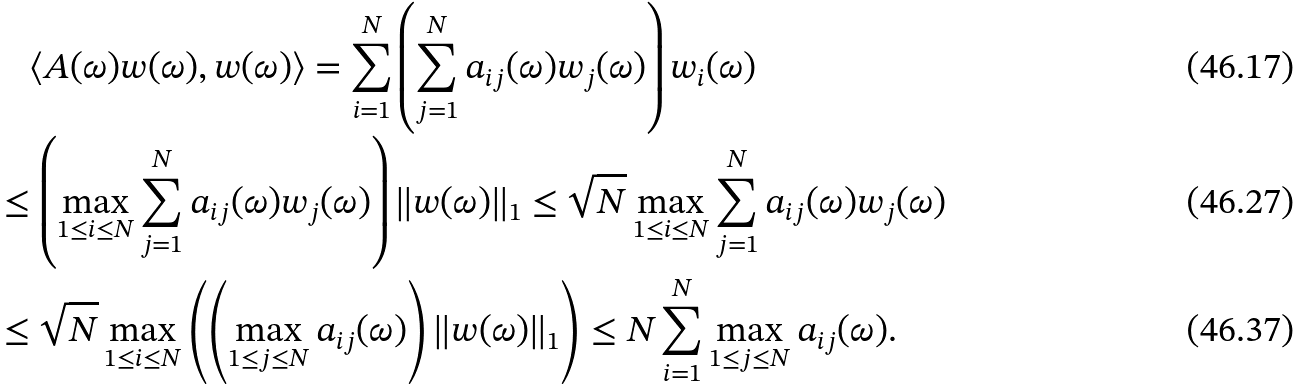Convert formula to latex. <formula><loc_0><loc_0><loc_500><loc_500>& \quad \langle A ( \omega ) w ( \omega ) , w ( \omega ) \rangle = \sum _ { i = 1 } ^ { N } \left ( \sum _ { j = 1 } ^ { N } a _ { i j } ( \omega ) w _ { j } ( \omega ) \right ) w _ { i } ( \omega ) \\ & \leq \left ( \max _ { 1 \leq i \leq N } \sum _ { j = 1 } ^ { N } a _ { i j } ( \omega ) w _ { j } ( \omega ) \right ) \| w ( \omega ) \| _ { 1 } \leq \sqrt { N } \max _ { 1 \leq i \leq N } \sum _ { j = 1 } ^ { N } a _ { i j } ( \omega ) w _ { j } ( \omega ) \\ & \leq \sqrt { N } \max _ { 1 \leq i \leq N } \left ( \left ( \max _ { 1 \leq j \leq N } a _ { i j } ( \omega ) \right ) \| w ( \omega ) \| _ { 1 } \right ) \leq N \sum _ { i = 1 } ^ { N } \max _ { 1 \leq j \leq N } a _ { i j } ( \omega ) .</formula> 